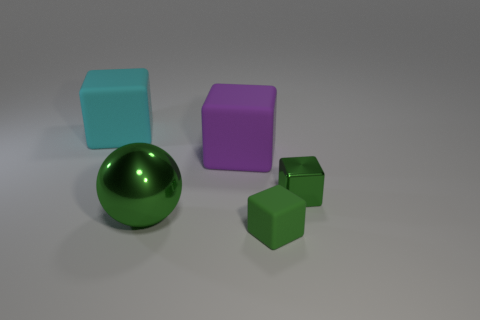There is another small block that is the same color as the tiny shiny cube; what is its material?
Offer a terse response. Rubber. Do the small matte block and the big sphere have the same color?
Provide a succinct answer. Yes. Are there any cyan cylinders that have the same material as the purple cube?
Give a very brief answer. No. There is a green object that is the same size as the cyan block; what is it made of?
Offer a terse response. Metal. Is the number of large metallic balls that are to the right of the large sphere less than the number of rubber cubes that are behind the cyan block?
Provide a short and direct response. No. There is a matte thing that is behind the small green matte block and to the right of the shiny ball; what shape is it?
Your response must be concise. Cube. What number of tiny green rubber things are the same shape as the big metal object?
Give a very brief answer. 0. There is a green cube that is the same material as the large ball; what is its size?
Your answer should be very brief. Small. Is the number of large cyan cubes greater than the number of brown metal balls?
Your response must be concise. Yes. The matte block on the left side of the purple thing is what color?
Ensure brevity in your answer.  Cyan. 